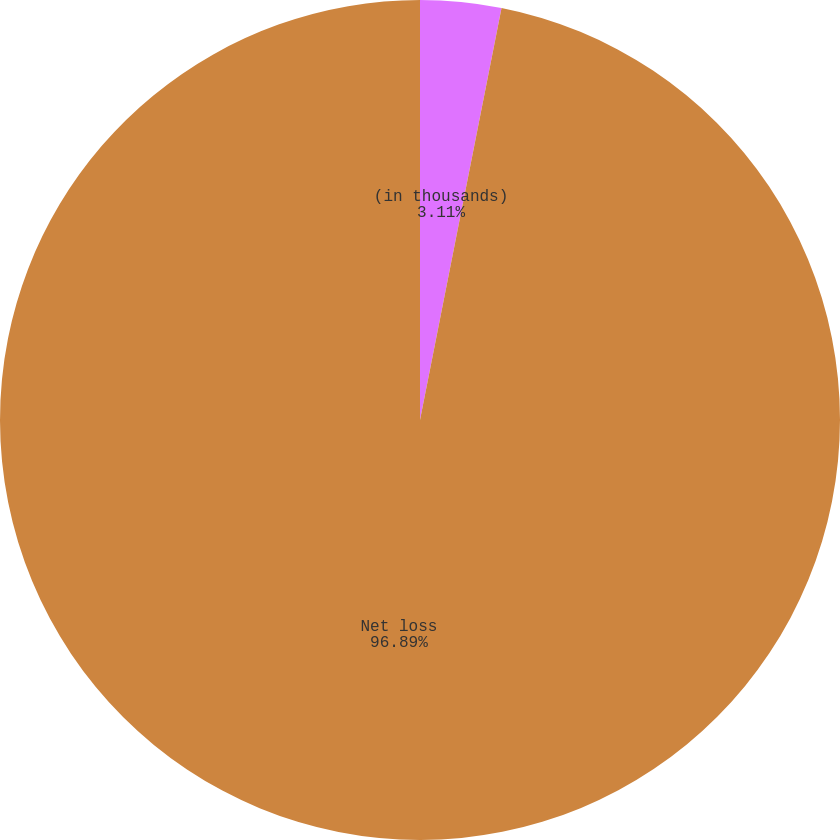Convert chart. <chart><loc_0><loc_0><loc_500><loc_500><pie_chart><fcel>(in thousands)<fcel>Net loss<nl><fcel>3.11%<fcel>96.89%<nl></chart> 